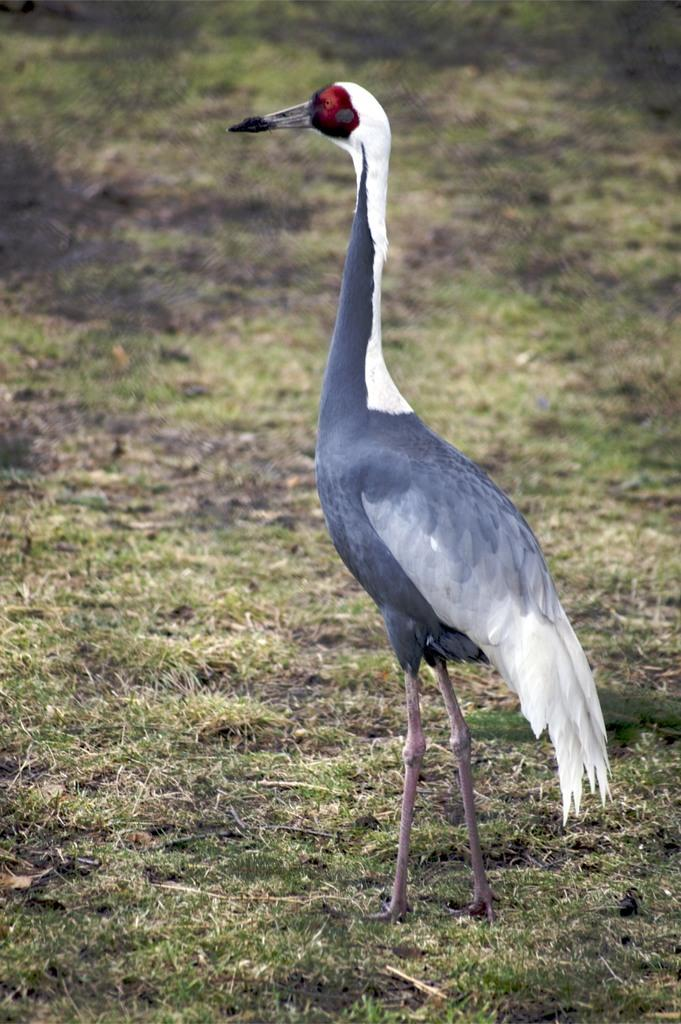What is the main subject in the image? There is a crane in the image. What type of natural environment is visible at the bottom of the image? There is grass visible at the bottom of the image. What type of apparel is the crane wearing in the image? Cranes are birds and do not wear apparel. --- Facts: 1. There is a person holding a camera in the image. 2. The person is standing on a bridge. 3. There is a river visible below the bridge. 4. The sky is visible in the background of the image. Absurd Topics: elephant, bicycle, dance Conversation: What is the person in the image holding? The person in the image is holding a camera. Where is the person standing in the image? The person is standing on a bridge. What type of natural environment is visible below the bridge? There is a river visible below the bridge. What is visible in the background of the image? The sky is visible in the background of the image. Reasoning: Let's think step by step in order to produce the conversation. We start by identifying the main subject in the image, which is the person holding a camera. Then, we expand the conversation to include the location of the person, which is on a bridge. Next, we describe the natural environment visible below the bridge, which is a river. Finally, we mention the sky visible in the background of the image. Each question is designed to elicit a specific detail about the image that is known from the provided facts. Absurd Question/Answer: Can you see an elephant riding a bicycle in the image? No, there is no elephant or bicycle present in the image. Is the person in the image dancing? There is no indication in the image that the person is dancing. 